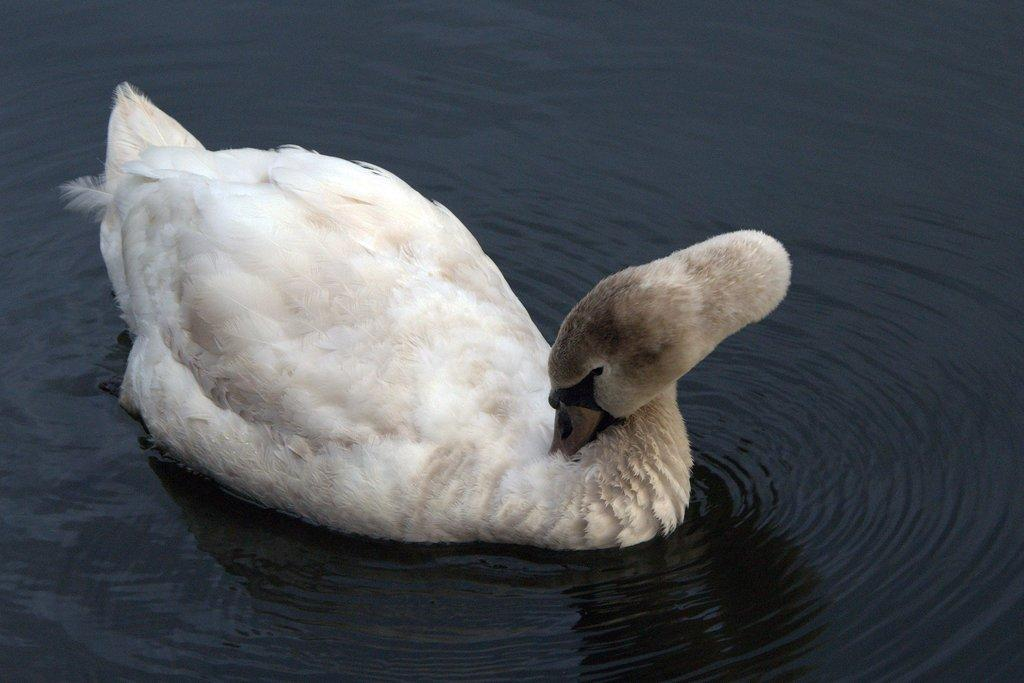What animal is present in the image? There is a duck in the image. Where is the duck located? The duck is in the water. What type of glove is the duck wearing in the image? There is no glove present in the image, and ducks do not wear gloves. 